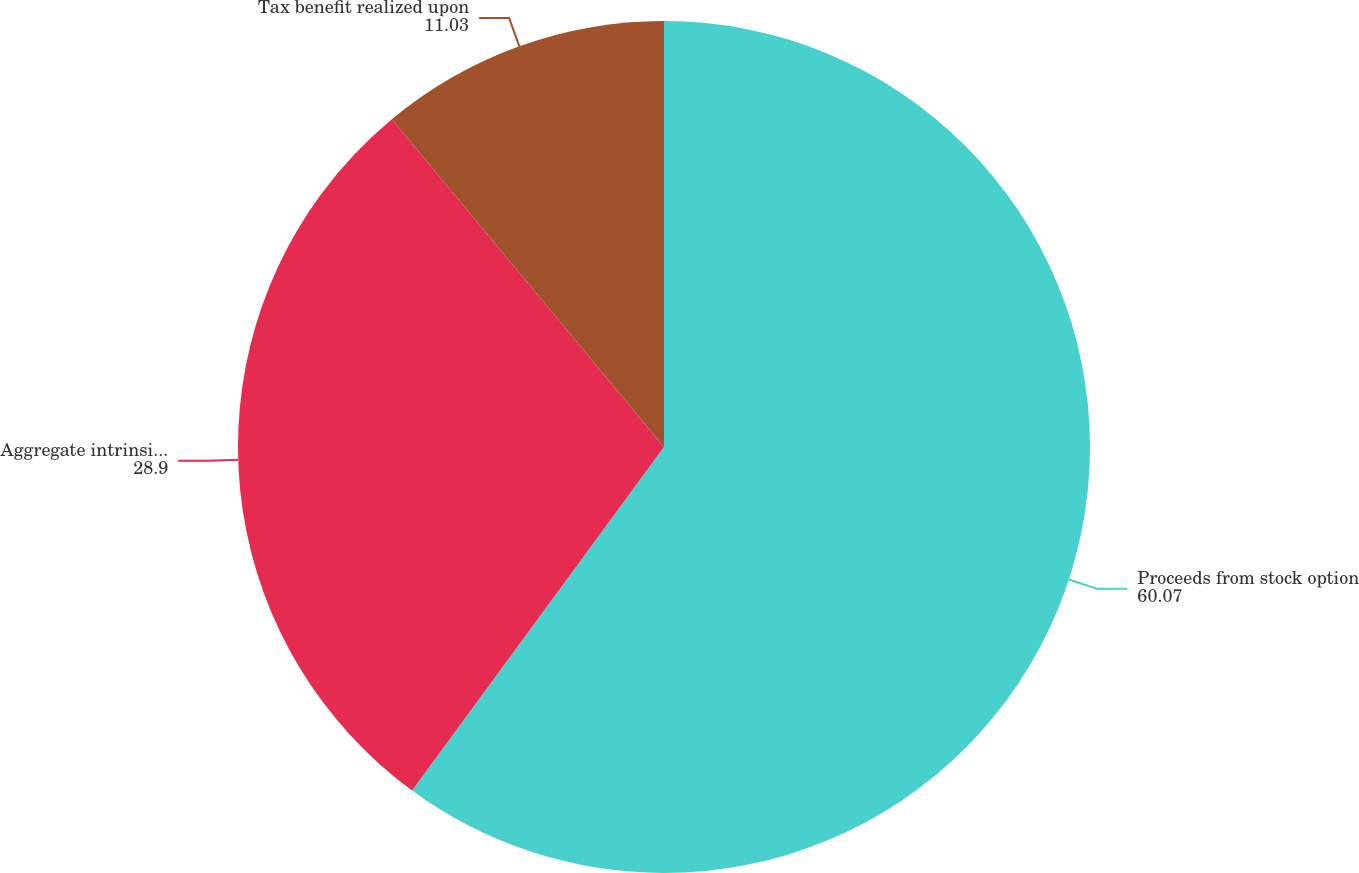<chart> <loc_0><loc_0><loc_500><loc_500><pie_chart><fcel>Proceeds from stock option<fcel>Aggregate intrinsic value<fcel>Tax benefit realized upon<nl><fcel>60.07%<fcel>28.9%<fcel>11.03%<nl></chart> 